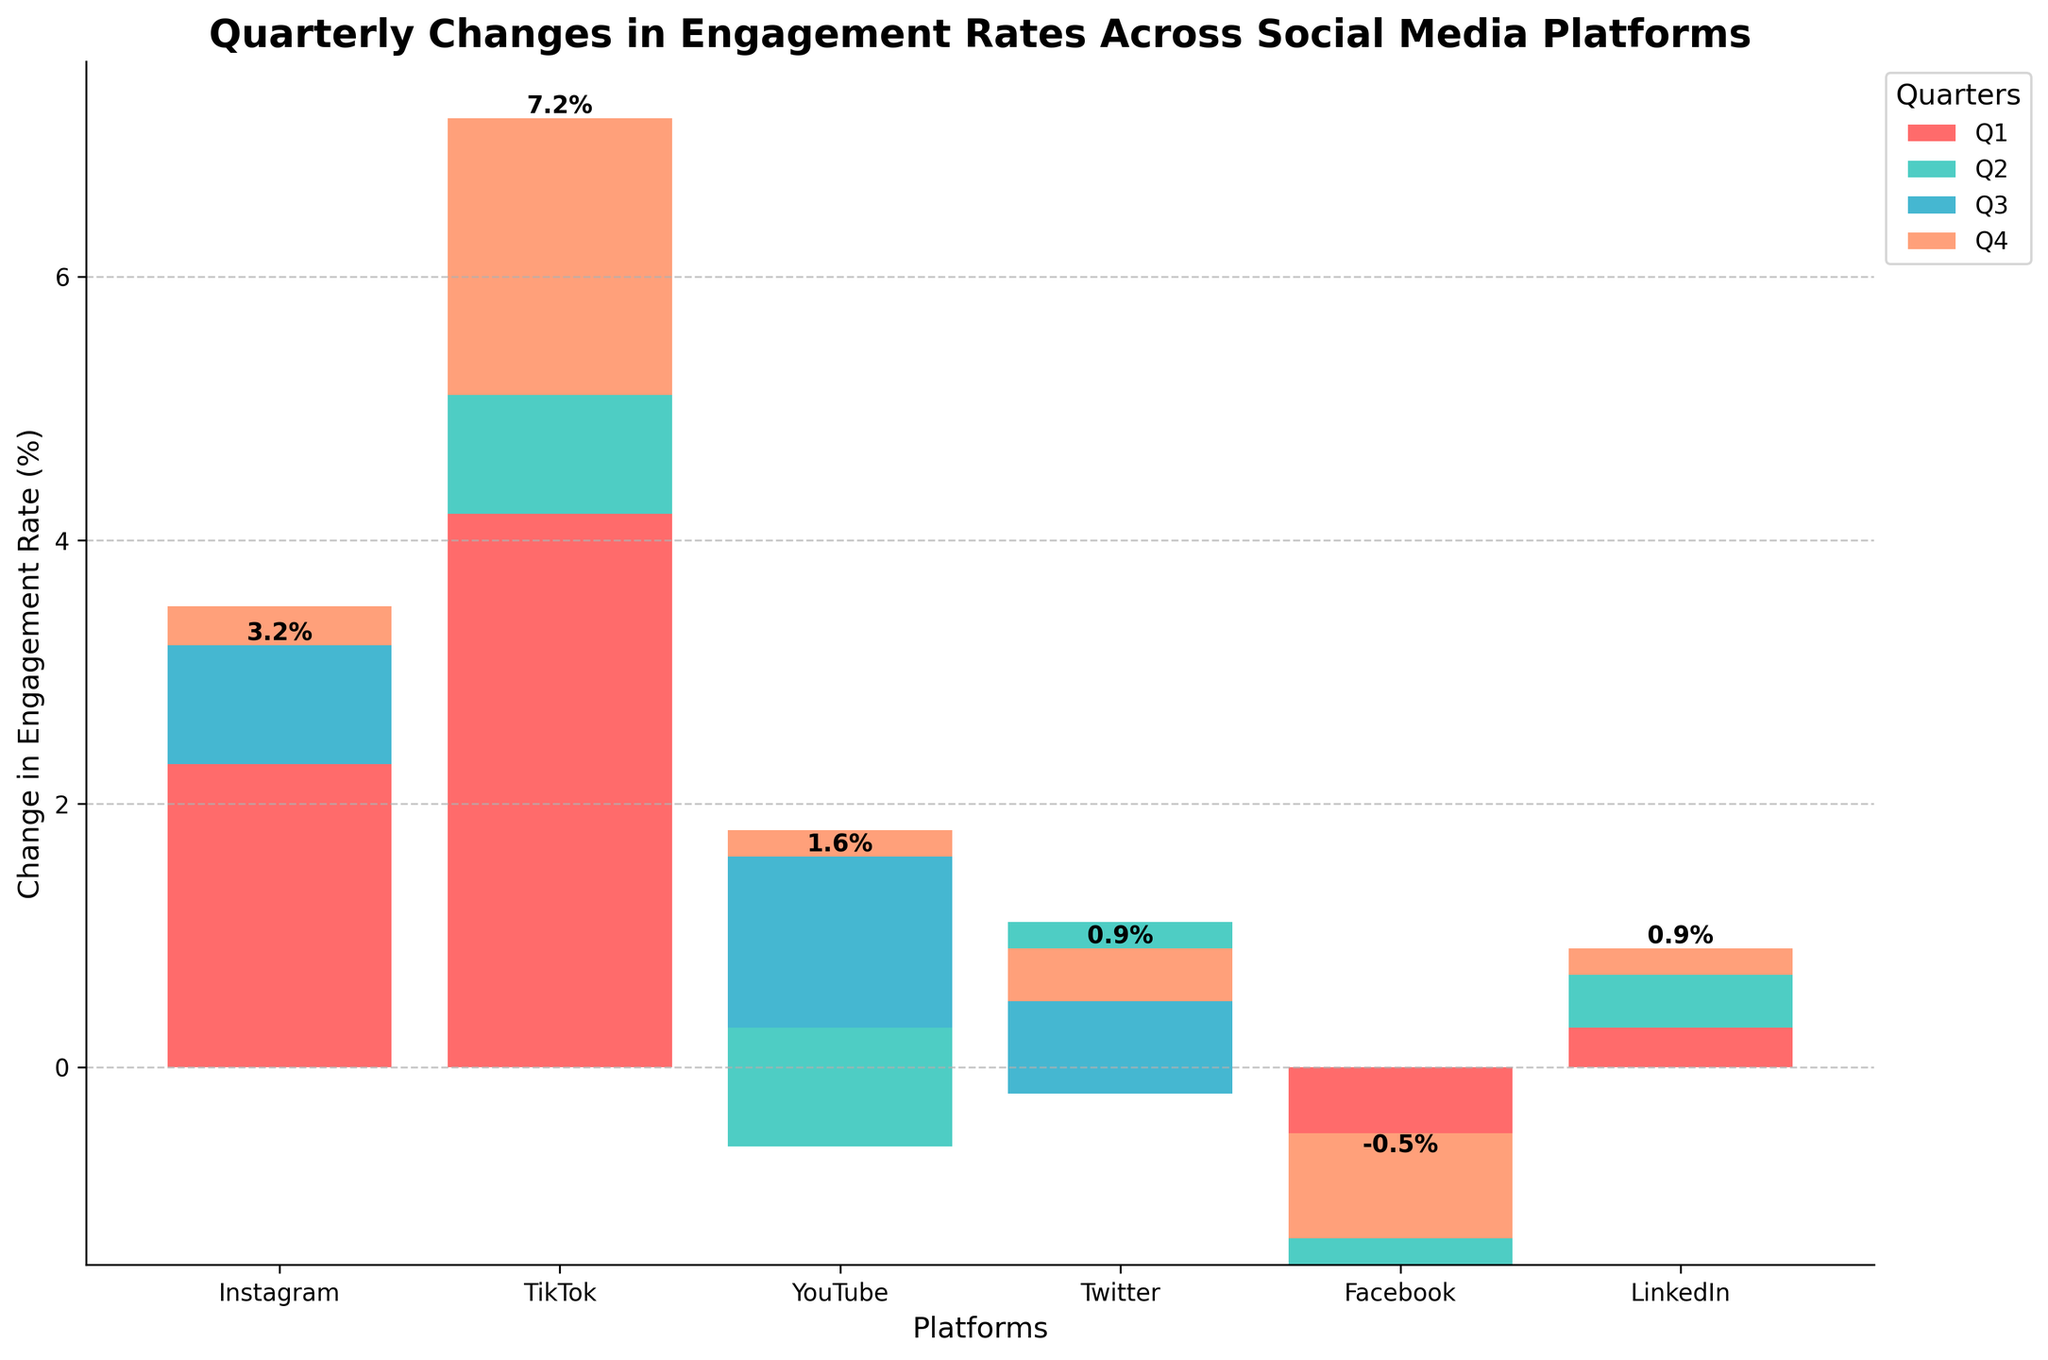What is the title of the chart? The title is typically found at the top of the chart and provides a summary of what the chart represents. In this case, it reads 'Quarterly Changes in Engagement Rates Across Social Media Platforms'.
Answer: Quarterly Changes in Engagement Rates Across Social Media Platforms Which platform had the highest increase in engagement rate in Q1? By looking at the bar heights in Q1, which is the first colored segment of each bar, you can see that TikTok has the highest increase compared to other platforms.
Answer: TikTok How much did YouTube's engagement rate change in Q2? For Q2 changes, you look at the second segment of the YouTube bar. The value is shown as part of the stacked bar graph. It is 0.9%.
Answer: 0.9% Which quarters did Instagram experience a decrease in engagement rate? To find this, observe the bars for Instagram (first group), noting which quarters have segments that go downward, indicated by negative values. Instagram shows decreases in Q2 (-0.5%) and Q4 (-0.3%).
Answer: Q2 and Q4 What is the total change in engagement rate for Facebook across all quarters? Sum up the values for Facebook across Q1, Q2, Q3, and Q4: -1.5 + 0.6 + (-0.4) + 0.8 = -0.5.
Answer: -0.5% How does the total engagement change of TikTok compare to that of Instagram? Calculate the total change for both platforms: Instagram (2.8 - 0.5 + 1.2 - 0.3 = 3.2) and TikTok (4.2 + 1.7 - 0.8 + 2.1 = 7.2). Comparing these totals, TikTok has a higher total increase.
Answer: TikTok's total increase is higher Which platform showed consistent growth across all quarters? To find consistency, examine each platform's bars and their direction across all four quarters. Only LinkedIn shows a consistent increase (values for all quarters are positive: 0.3, 0.5, 0.1, 0.2).
Answer: LinkedIn Between Twitter and YouTube, which platform had a more positive overall engagement change? Calculate the total changes: Twitter (1.1 - 1.3 + 0.7 + 0.4 = 0.9) and YouTube (-0.6 + 0.9 + 1.5 - 0.2 = 1.6). YouTube has a more positive change overall.
Answer: YouTube What is the engagement rate change for LinkedIn in Q3, and how does it compare to LinkedIn's Q4 change? For Q3, LinkedIn shows -0.1%. For Q4, LinkedIn shows 0.2%. Comparing these, Q3 had a decrease while Q4 had an increase.
Answer: Q3: -0.1%, Q4: 0.2% Was there any platform with a negative total change? Calculate the total changes for all platforms and check if any are negative. Facebook is the only platform with a negative total change: -0.5%.
Answer: Facebook 